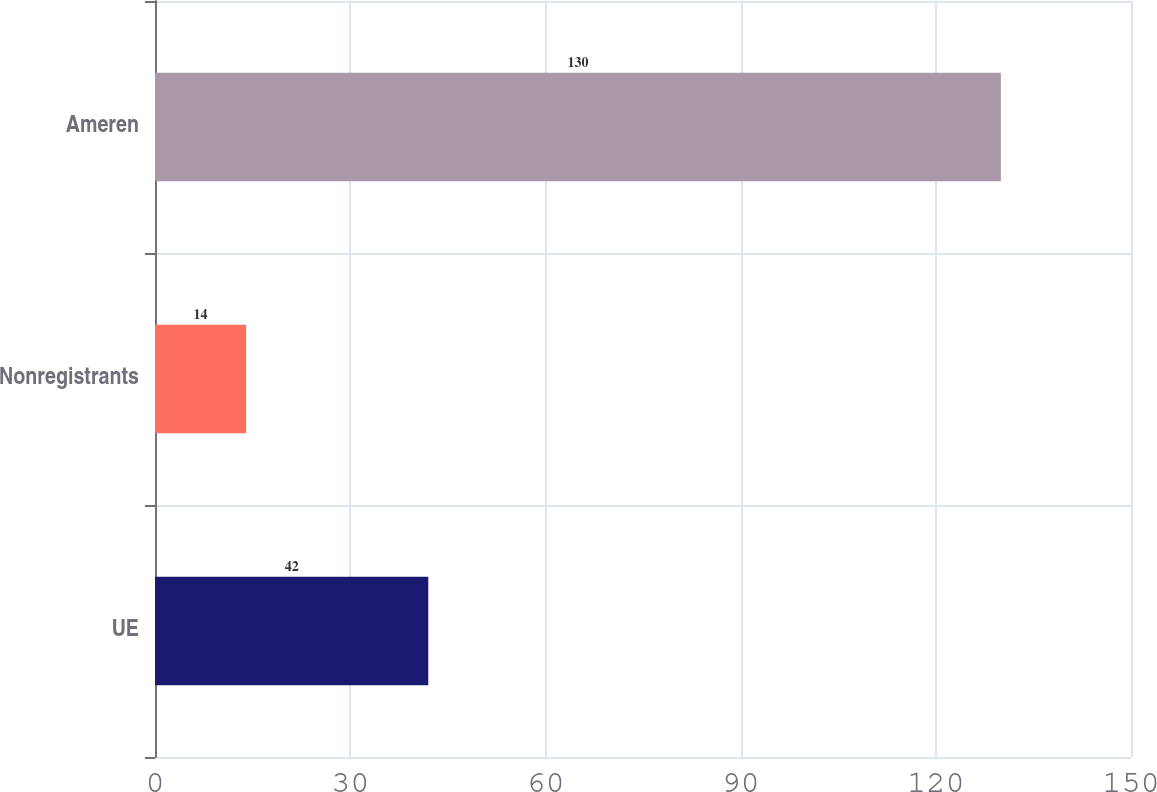Convert chart. <chart><loc_0><loc_0><loc_500><loc_500><bar_chart><fcel>UE<fcel>Nonregistrants<fcel>Ameren<nl><fcel>42<fcel>14<fcel>130<nl></chart> 